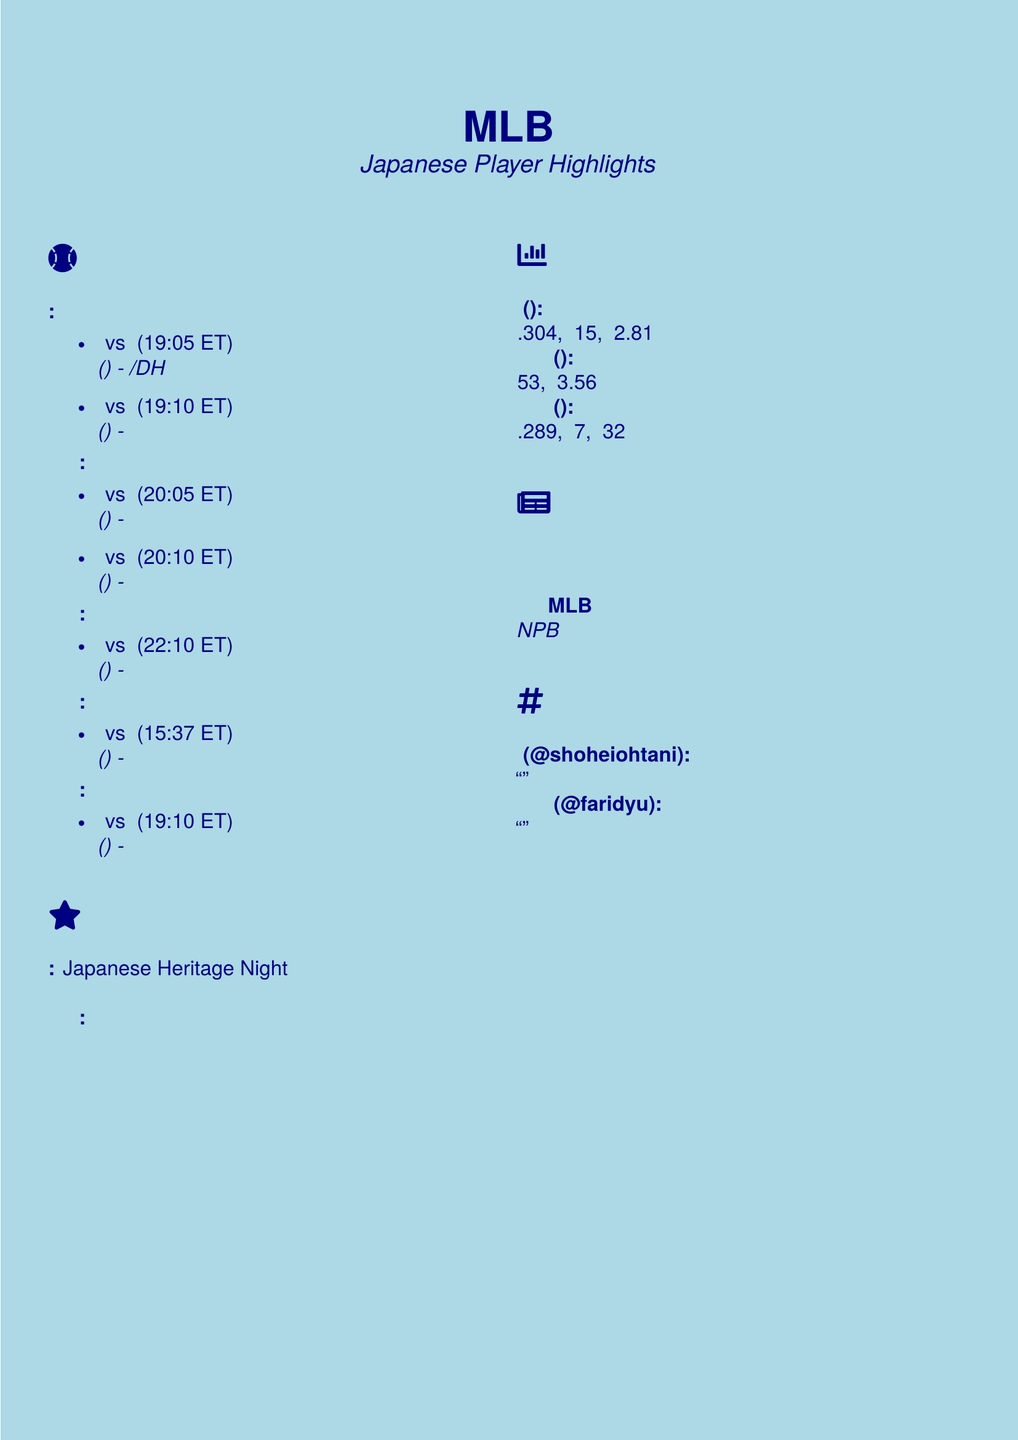What game is scheduled on Monday? The document lists the games scheduled for each day, with Monday including the matchup between the New York Yankees and the Los Angeles Angels.
Answer: New York Yankees vs. Los Angeles Angels Who is the Japanese player highlighted for the game on Tuesday? The Tuesday schedule highlights Yu Darvish as the Japanese player in the Padres vs. Cubs game.
Answer: Yu Darvish (Padres) What time does the Wednesday game start? The document specifies the start time for the Cardinals vs. Dodgers game on Wednesday is 10:10 PM ET.
Answer: 10:10 PM ET How many home runs does Masataka Yoshida have? The Japanese player statistics section provides Masataka Yoshida's home runs total as part of his performance metrics.
Answer: 7 What special event is occurring on Wednesday? The document outlines a special event called Japanese Heritage Night happening on Wednesday at Dodger Stadium.
Answer: Japanese Heritage Night What is Shohei Ohtani's ERA? The document includes specific stats for Shohei Ohtani, mentioning his Earned Run Average (ERA).
Answer: 2.81 Which player made an impressive MLB debut according to the news? The baseball news section mentions Yoshinobu Yamamoto having an impressive performance in his debut.
Answer: Yoshinobu Yamamoto What is the date for the Shohei Ohtani bobblehead giveaway? The document specifies that the giveaway event takes place on Monday.
Answer: Monday 